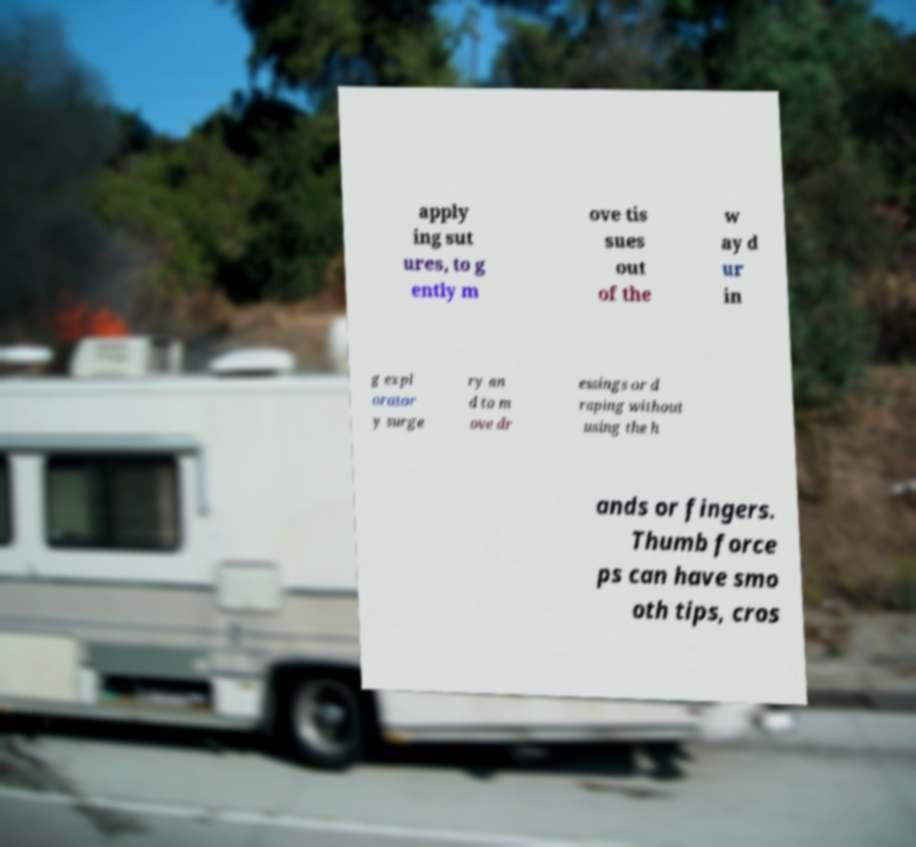For documentation purposes, I need the text within this image transcribed. Could you provide that? apply ing sut ures, to g ently m ove tis sues out of the w ay d ur in g expl orator y surge ry an d to m ove dr essings or d raping without using the h ands or fingers. Thumb force ps can have smo oth tips, cros 